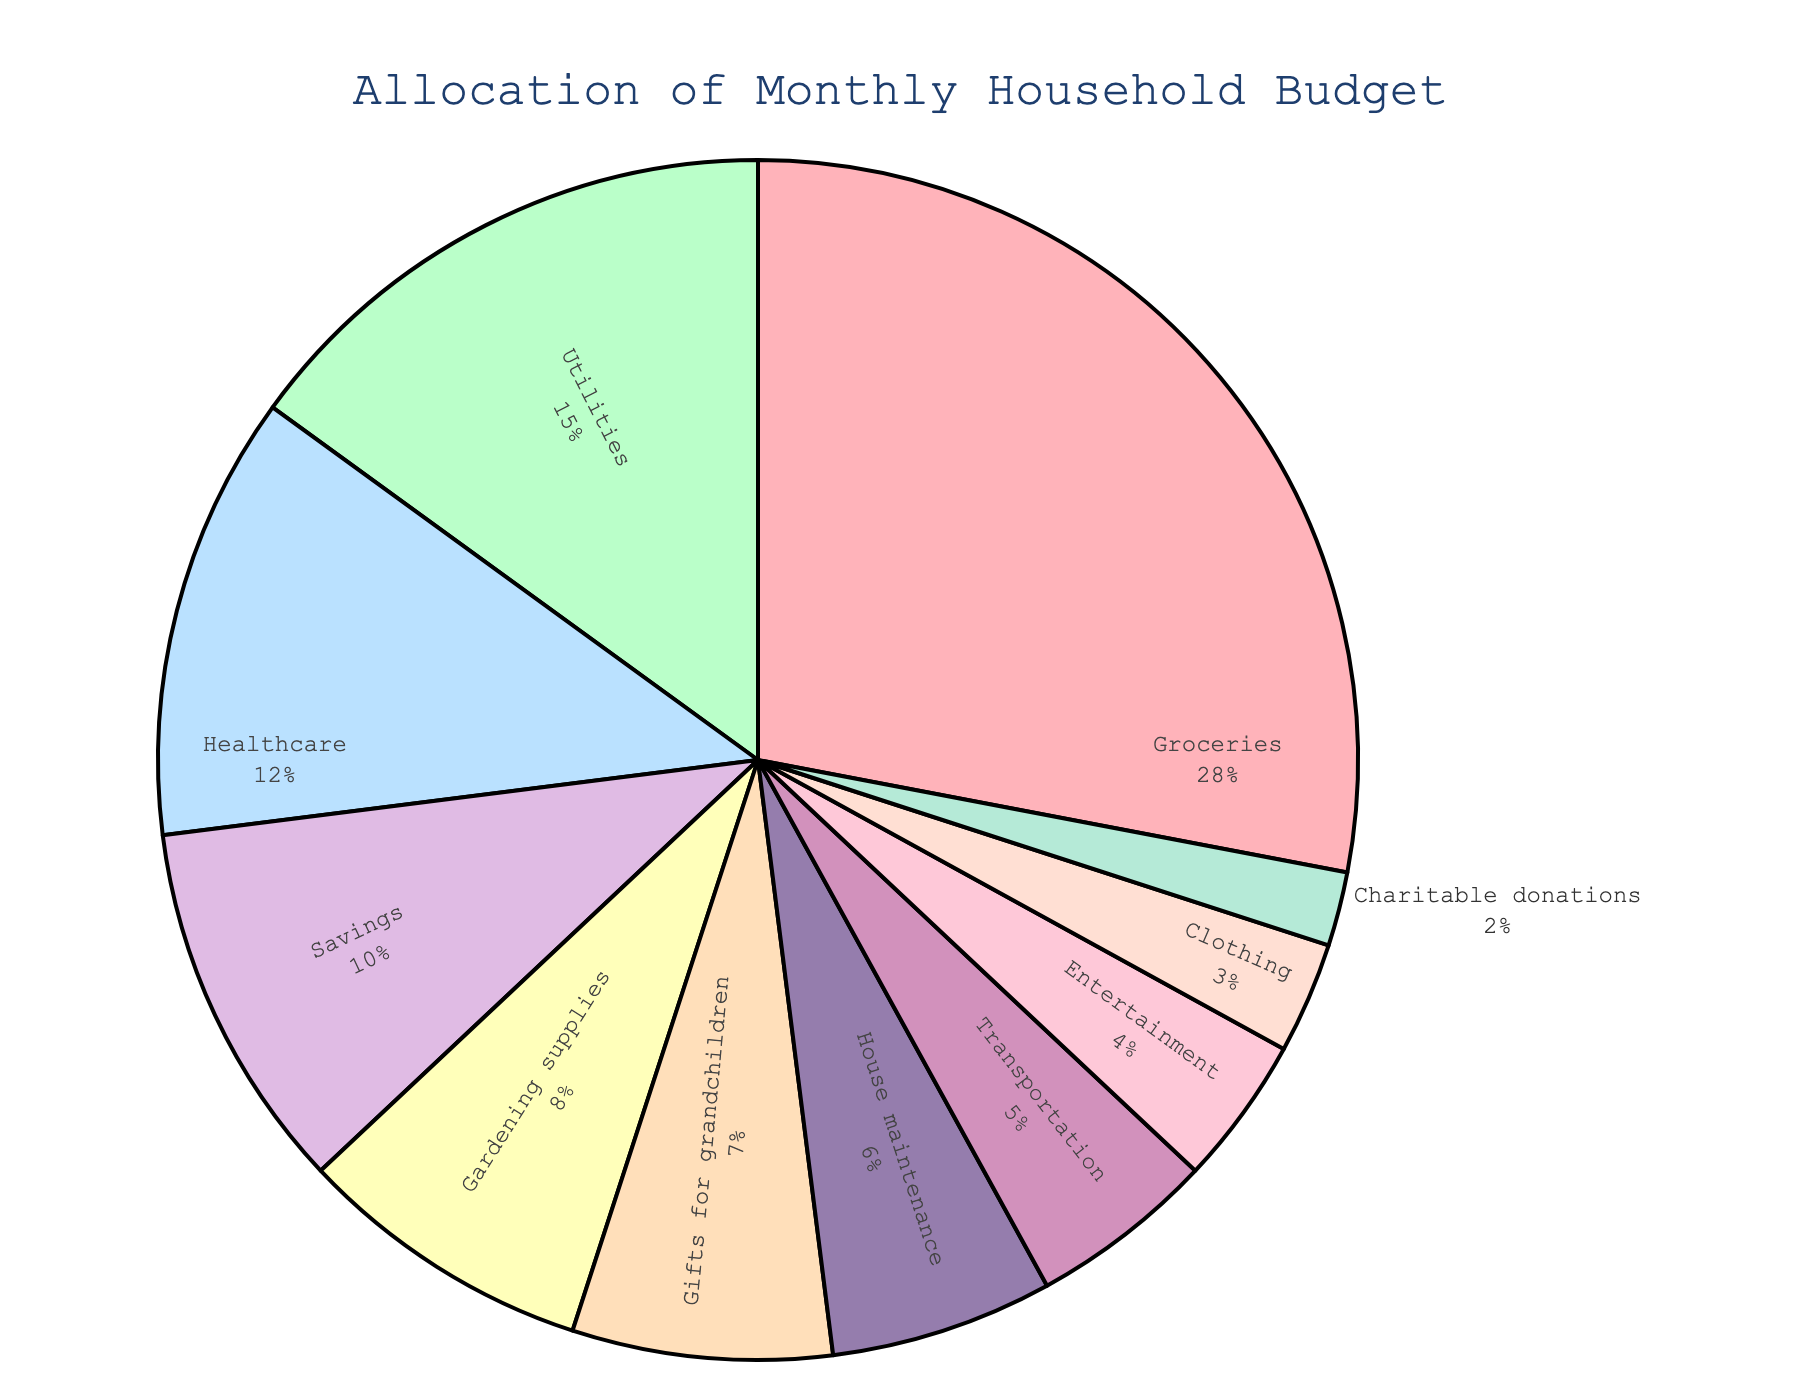What's the total percentage for Utilities, Healthcare, and House maintenance combined? Add up the percentages for Utilities (15%), Healthcare (12%), and House maintenance (6%). 15% + 12% + 6% = 33%
Answer: 33% Which category has the smallest allocation in the monthly budget? Look for the category with the smallest percentage in the pie chart, which is Charitable donations at 2%.
Answer: Charitable donations Are the allocations for Groceries and Healthcare equal to the allocation for Savings? Add the percentages for Groceries (28%) and Healthcare (12%), and compare it to Savings (10%). 28% + 12% = 40%, which is not equal to 10%.
Answer: No Which categories have an allocation of more than 10%? Examine the pie chart for categories with an allocation greater than 10%. Groceries (28%) and Utilities (15%) are more than 10%.
Answer: Groceries and Utilities What is the difference in the allocation between Groceries and Transportation? Subtract the percentage for Transportation (5%) from the percentage for Groceries (28%). 28% - 5% = 23%
Answer: 23% What percentage is allocated to Gardening supplies? Inspect the pie chart and find the percentage for Gardening supplies, which is 8%.
Answer: 8% If the budget for Gifts for grandchildren is doubled, would it exceed the allocation for Savings? Double the percentage for Gifts for grandchildren (7% * 2 = 14%) and compare it to the percentage for Savings (10%). 14% is larger than 10%.
Answer: Yes Which sectors combined account for less than 10% of the total budget? Identify categories with less than 10% individually and sum them. Transportation (5%), Entertainment (4%), Clothing (3%), and Charitable donations (2%) altogether are 5% + 4% + 3% + 2% = 14% which is more than 10%, so look for smaller combinations. Clothing and Charitable donations together are 3% + 2% = 5%.
Answer: None What would be the new percentage for Gardening supplies if its allocation is increased by 50%? Increase the current allocation of Gardening supplies (8%) by 50%. 8% + (8% * 0.5) = 8% + 4% = 12%.
Answer: 12% 